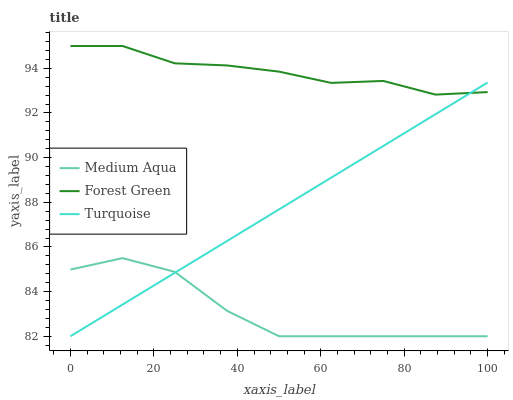Does Medium Aqua have the minimum area under the curve?
Answer yes or no. Yes. Does Forest Green have the maximum area under the curve?
Answer yes or no. Yes. Does Turquoise have the minimum area under the curve?
Answer yes or no. No. Does Turquoise have the maximum area under the curve?
Answer yes or no. No. Is Turquoise the smoothest?
Answer yes or no. Yes. Is Medium Aqua the roughest?
Answer yes or no. Yes. Is Medium Aqua the smoothest?
Answer yes or no. No. Is Turquoise the roughest?
Answer yes or no. No. Does Medium Aqua have the lowest value?
Answer yes or no. Yes. Does Forest Green have the highest value?
Answer yes or no. Yes. Does Turquoise have the highest value?
Answer yes or no. No. Is Medium Aqua less than Forest Green?
Answer yes or no. Yes. Is Forest Green greater than Medium Aqua?
Answer yes or no. Yes. Does Forest Green intersect Turquoise?
Answer yes or no. Yes. Is Forest Green less than Turquoise?
Answer yes or no. No. Is Forest Green greater than Turquoise?
Answer yes or no. No. Does Medium Aqua intersect Forest Green?
Answer yes or no. No. 